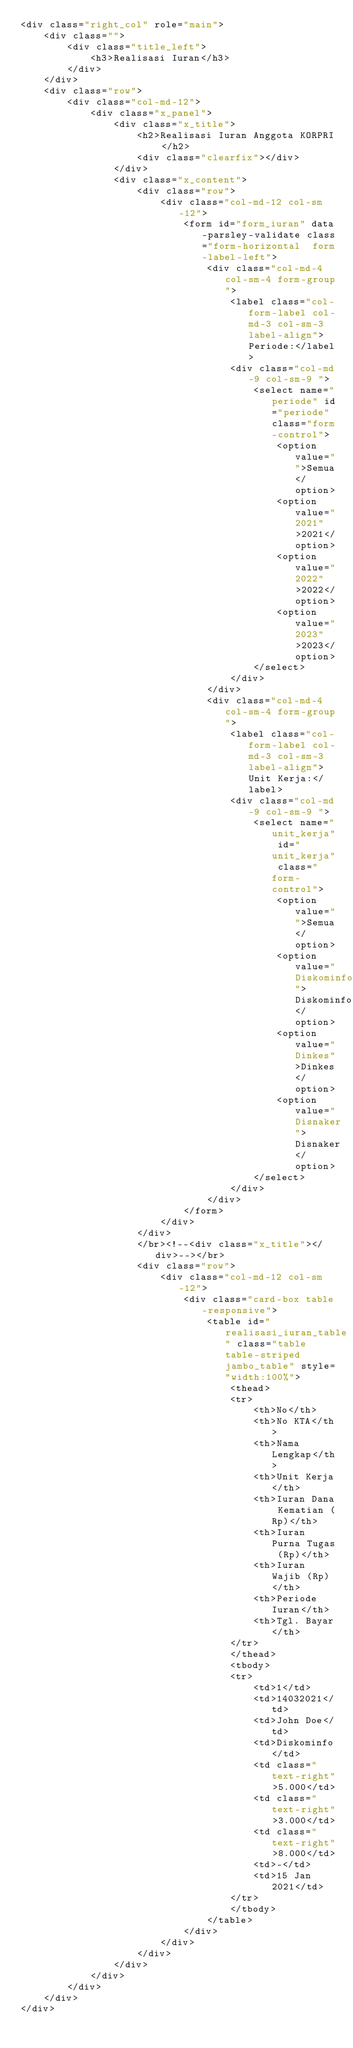<code> <loc_0><loc_0><loc_500><loc_500><_PHP_><div class="right_col" role="main">
	<div class="">
		<div class="title_left">
			<h3>Realisasi Iuran</h3>
		</div>
	</div>
	<div class="row">
		<div class="col-md-12">
			<div class="x_panel">
				<div class="x_title">
					<h2>Realisasi Iuran Anggota KORPRI </h2>
					<div class="clearfix"></div>
				</div>
				<div class="x_content">
					<div class="row">
						<div class="col-md-12 col-sm-12">
							<form id="form_iuran" data-parsley-validate class="form-horizontal 	form-label-left">
								<div class="col-md-4 col-sm-4 form-group">
									<label class="col-form-label col-md-3 col-sm-3 label-align">Periode:</label>
									<div class="col-md-9 col-sm-9 ">
										<select name="periode" id="periode" class="form-control">
											<option value="">Semua</option>
											<option value="2021">2021</option>
											<option value="2022">2022</option>
											<option value="2023">2023</option>
										</select>
									</div>
								</div>
								<div class="col-md-4 col-sm-4 form-group">
									<label class="col-form-label col-md-3 col-sm-3 label-align">Unit Kerja:</label>
									<div class="col-md-9 col-sm-9 ">
										<select name="unit_kerja" id="unit_kerja" class="form-control">
											<option value="">Semua</option>
											<option value="Diskominfo">Diskominfo</option>
											<option value="Dinkes">Dinkes</option>
											<option value="Disnaker">Disnaker</option>
										</select>
									</div>
								</div>
							</form>
						</div>
					</div>
					</br><!--<div class="x_title"></div>--></br>
					<div class="row">
						<div class="col-md-12 col-sm-12">
							<div class="card-box table-responsive">
								<table id="realisasi_iuran_table" class="table table-striped jambo_table" style="width:100%">
									<thead>
									<tr>
										<th>No</th>
										<th>No KTA</th>
										<th>Nama Lengkap</th>
										<th>Unit Kerja</th>
										<th>Iuran Dana Kematian (Rp)</th>
										<th>Iuran Purna Tugas (Rp)</th>
										<th>Iuran Wajib (Rp)</th>
										<th>Periode Iuran</th>
										<th>Tgl. Bayar</th>
									</tr>
									</thead>
									<tbody>
									<tr>
										<td>1</td>
										<td>14032021</td>
										<td>John Doe</td>
										<td>Diskominfo</td>
										<td class="text-right">5.000</td>
										<td class="text-right">3.000</td>
										<td class="text-right">8.000</td>
										<td>-</td>
										<td>15 Jan 2021</td>
									</tr>
									</tbody>
								</table>
							</div>
						</div>
					</div>
				</div>
			</div>
		</div>
	</div>
</div>
</code> 